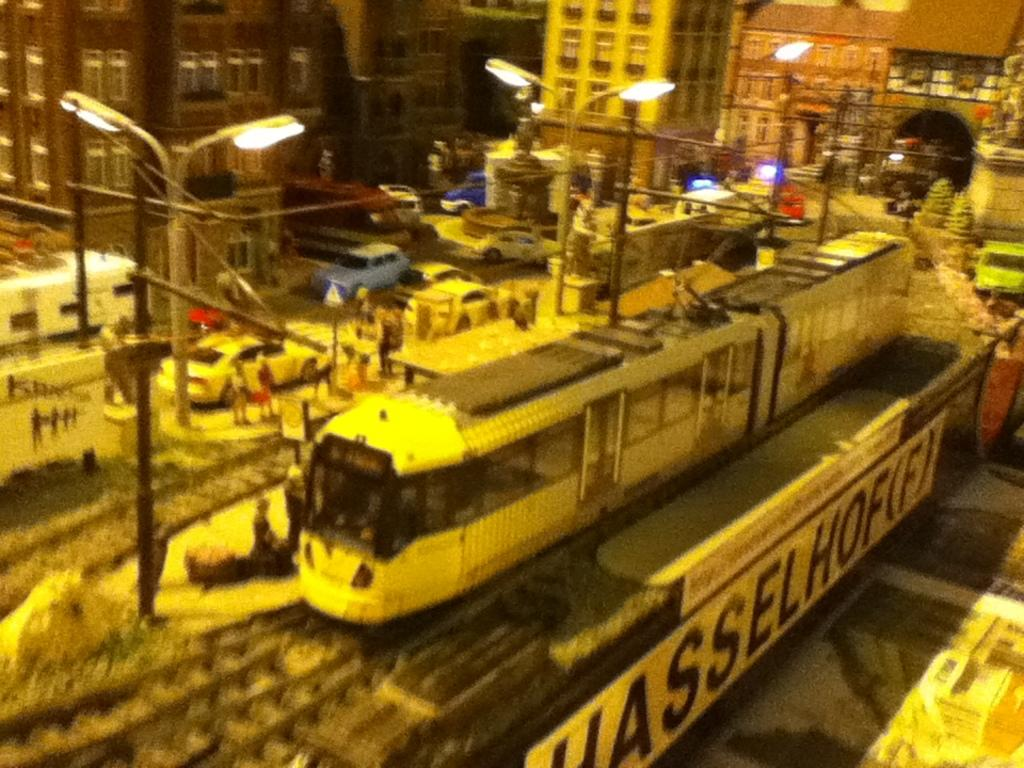Provide a one-sentence caption for the provided image. A train is going by a fence that has a banner that says Hasselhoff. 